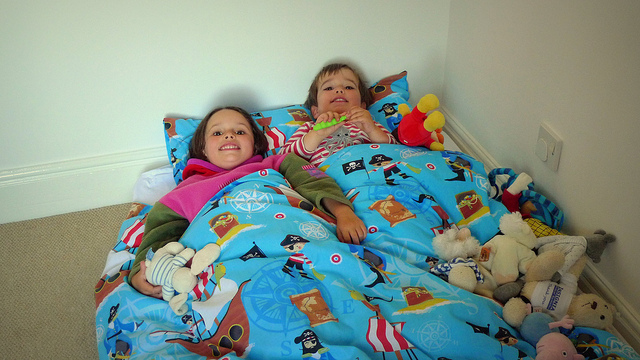Please transcribe the text information in this image. S E 